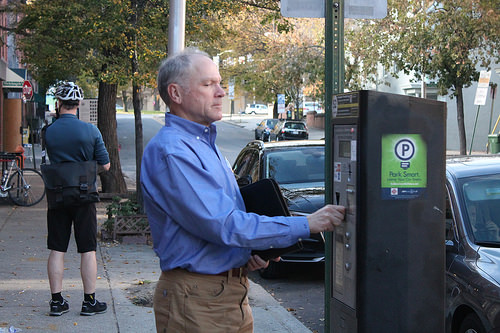<image>
Can you confirm if the man is on the car? No. The man is not positioned on the car. They may be near each other, but the man is not supported by or resting on top of the car. 